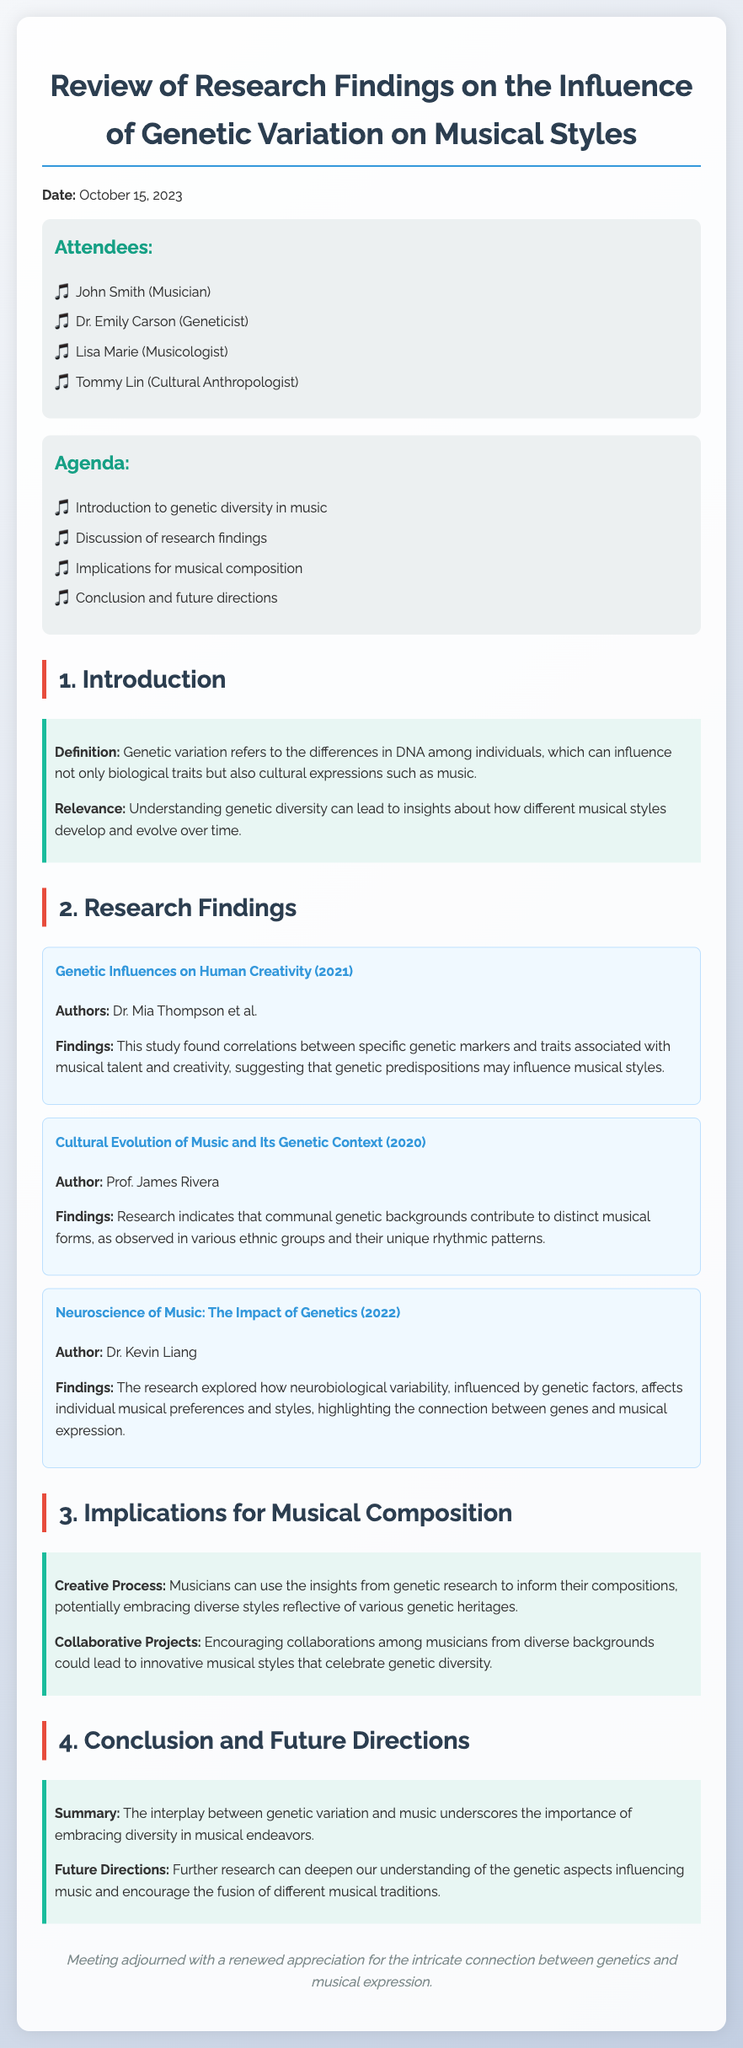What is the date of the meeting? The date of the meeting is mentioned at the beginning of the document as October 15, 2023.
Answer: October 15, 2023 Who authored the study "Genetic Influences on Human Creativity"? The authors of the study are listed in the research findings section, specifically Dr. Mia Thompson et al.
Answer: Dr. Mia Thompson et al What was a key finding of Prof. James Rivera's research? The document indicates that Prof. James Rivera's research found that communal genetic backgrounds contribute to distinct musical forms.
Answer: Communal genetic backgrounds contribute to distinct musical forms What implications for musical composition were discussed? The meeting minutes outline that musicians can use insights from genetic research to inform their compositions.
Answer: Use insights from genetic research What type of diversity is emphasized in the conclusion? The conclusion highlights the importance of embracing diversity in musical endeavors.
Answer: Diversity How many attendees were present at the meeting? The number of attendees is found in the attendees section where four individuals are listed.
Answer: Four What is the focus of future research directions? Future research directions encourage the fusion of different musical traditions and an understanding of genetic aspects influencing music.
Answer: Fusion of different musical traditions What does the key point on the creative process suggest? The creative process section suggests that musicians could embrace diverse styles reflective of various genetic heritages.
Answer: Embrace diverse styles reflective of various genetic heritages 